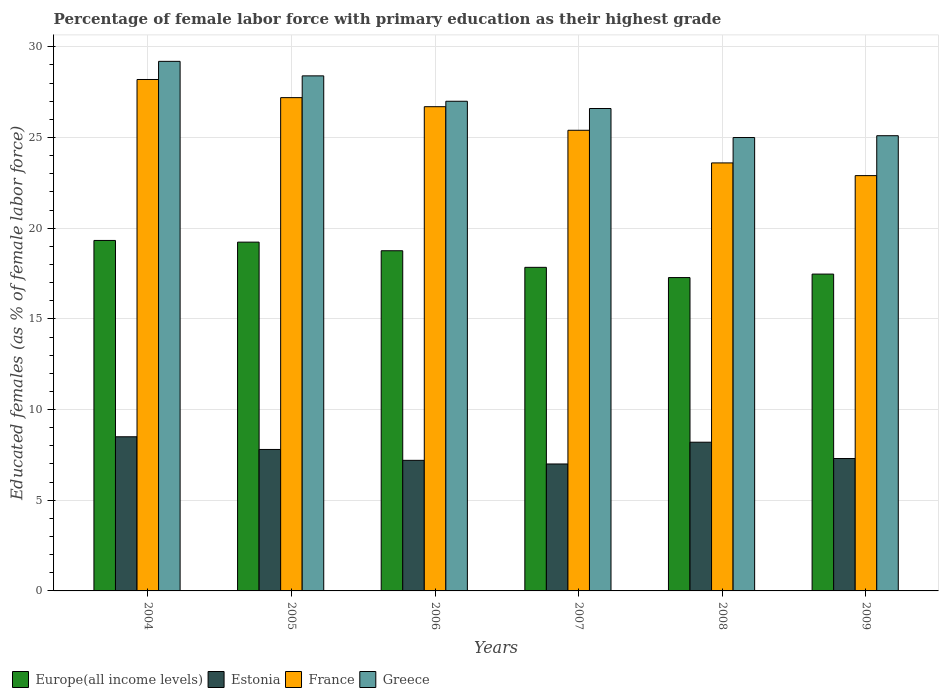How many different coloured bars are there?
Make the answer very short. 4. How many groups of bars are there?
Provide a succinct answer. 6. Are the number of bars per tick equal to the number of legend labels?
Ensure brevity in your answer.  Yes. Are the number of bars on each tick of the X-axis equal?
Your answer should be compact. Yes. What is the percentage of female labor force with primary education in Greece in 2009?
Make the answer very short. 25.1. Across all years, what is the maximum percentage of female labor force with primary education in Europe(all income levels)?
Provide a short and direct response. 19.32. Across all years, what is the minimum percentage of female labor force with primary education in France?
Keep it short and to the point. 22.9. In which year was the percentage of female labor force with primary education in Europe(all income levels) maximum?
Give a very brief answer. 2004. What is the total percentage of female labor force with primary education in Greece in the graph?
Provide a short and direct response. 161.3. What is the difference between the percentage of female labor force with primary education in Europe(all income levels) in 2004 and that in 2008?
Your answer should be compact. 2.05. What is the difference between the percentage of female labor force with primary education in Europe(all income levels) in 2007 and the percentage of female labor force with primary education in Estonia in 2004?
Offer a terse response. 9.34. What is the average percentage of female labor force with primary education in Estonia per year?
Provide a short and direct response. 7.67. In the year 2006, what is the difference between the percentage of female labor force with primary education in France and percentage of female labor force with primary education in Greece?
Your response must be concise. -0.3. In how many years, is the percentage of female labor force with primary education in Greece greater than 10 %?
Your answer should be compact. 6. What is the ratio of the percentage of female labor force with primary education in Europe(all income levels) in 2004 to that in 2006?
Your answer should be very brief. 1.03. Is the percentage of female labor force with primary education in Greece in 2005 less than that in 2009?
Provide a short and direct response. No. Is the difference between the percentage of female labor force with primary education in France in 2007 and 2009 greater than the difference between the percentage of female labor force with primary education in Greece in 2007 and 2009?
Give a very brief answer. Yes. What is the difference between the highest and the second highest percentage of female labor force with primary education in Europe(all income levels)?
Ensure brevity in your answer.  0.09. What is the difference between the highest and the lowest percentage of female labor force with primary education in Europe(all income levels)?
Your answer should be very brief. 2.05. In how many years, is the percentage of female labor force with primary education in Europe(all income levels) greater than the average percentage of female labor force with primary education in Europe(all income levels) taken over all years?
Provide a short and direct response. 3. Is the sum of the percentage of female labor force with primary education in France in 2005 and 2006 greater than the maximum percentage of female labor force with primary education in Europe(all income levels) across all years?
Make the answer very short. Yes. Is it the case that in every year, the sum of the percentage of female labor force with primary education in France and percentage of female labor force with primary education in Europe(all income levels) is greater than the sum of percentage of female labor force with primary education in Greece and percentage of female labor force with primary education in Estonia?
Your answer should be compact. No. What does the 1st bar from the left in 2007 represents?
Offer a very short reply. Europe(all income levels). What does the 4th bar from the right in 2007 represents?
Your response must be concise. Europe(all income levels). Is it the case that in every year, the sum of the percentage of female labor force with primary education in Greece and percentage of female labor force with primary education in Estonia is greater than the percentage of female labor force with primary education in Europe(all income levels)?
Your answer should be very brief. Yes. How many bars are there?
Provide a succinct answer. 24. Are all the bars in the graph horizontal?
Provide a succinct answer. No. What is the difference between two consecutive major ticks on the Y-axis?
Your answer should be very brief. 5. Are the values on the major ticks of Y-axis written in scientific E-notation?
Your answer should be very brief. No. Does the graph contain any zero values?
Keep it short and to the point. No. Where does the legend appear in the graph?
Make the answer very short. Bottom left. How many legend labels are there?
Provide a succinct answer. 4. How are the legend labels stacked?
Your answer should be compact. Horizontal. What is the title of the graph?
Your response must be concise. Percentage of female labor force with primary education as their highest grade. What is the label or title of the Y-axis?
Your response must be concise. Educated females (as % of female labor force). What is the Educated females (as % of female labor force) in Europe(all income levels) in 2004?
Keep it short and to the point. 19.32. What is the Educated females (as % of female labor force) of France in 2004?
Your response must be concise. 28.2. What is the Educated females (as % of female labor force) in Greece in 2004?
Your answer should be very brief. 29.2. What is the Educated females (as % of female labor force) of Europe(all income levels) in 2005?
Provide a succinct answer. 19.23. What is the Educated females (as % of female labor force) of Estonia in 2005?
Provide a short and direct response. 7.8. What is the Educated females (as % of female labor force) in France in 2005?
Offer a very short reply. 27.2. What is the Educated females (as % of female labor force) of Greece in 2005?
Make the answer very short. 28.4. What is the Educated females (as % of female labor force) in Europe(all income levels) in 2006?
Offer a terse response. 18.76. What is the Educated females (as % of female labor force) of Estonia in 2006?
Offer a terse response. 7.2. What is the Educated females (as % of female labor force) of France in 2006?
Offer a very short reply. 26.7. What is the Educated females (as % of female labor force) of Greece in 2006?
Ensure brevity in your answer.  27. What is the Educated females (as % of female labor force) of Europe(all income levels) in 2007?
Make the answer very short. 17.84. What is the Educated females (as % of female labor force) of France in 2007?
Offer a very short reply. 25.4. What is the Educated females (as % of female labor force) of Greece in 2007?
Ensure brevity in your answer.  26.6. What is the Educated females (as % of female labor force) in Europe(all income levels) in 2008?
Your response must be concise. 17.28. What is the Educated females (as % of female labor force) of Estonia in 2008?
Make the answer very short. 8.2. What is the Educated females (as % of female labor force) of France in 2008?
Give a very brief answer. 23.6. What is the Educated females (as % of female labor force) in Greece in 2008?
Ensure brevity in your answer.  25. What is the Educated females (as % of female labor force) in Europe(all income levels) in 2009?
Your answer should be very brief. 17.47. What is the Educated females (as % of female labor force) in Estonia in 2009?
Provide a succinct answer. 7.3. What is the Educated females (as % of female labor force) in France in 2009?
Give a very brief answer. 22.9. What is the Educated females (as % of female labor force) of Greece in 2009?
Your response must be concise. 25.1. Across all years, what is the maximum Educated females (as % of female labor force) in Europe(all income levels)?
Your answer should be compact. 19.32. Across all years, what is the maximum Educated females (as % of female labor force) in France?
Your answer should be compact. 28.2. Across all years, what is the maximum Educated females (as % of female labor force) in Greece?
Ensure brevity in your answer.  29.2. Across all years, what is the minimum Educated females (as % of female labor force) of Europe(all income levels)?
Make the answer very short. 17.28. Across all years, what is the minimum Educated females (as % of female labor force) in France?
Your response must be concise. 22.9. Across all years, what is the minimum Educated females (as % of female labor force) in Greece?
Keep it short and to the point. 25. What is the total Educated females (as % of female labor force) in Europe(all income levels) in the graph?
Offer a very short reply. 109.9. What is the total Educated females (as % of female labor force) in France in the graph?
Give a very brief answer. 154. What is the total Educated females (as % of female labor force) in Greece in the graph?
Make the answer very short. 161.3. What is the difference between the Educated females (as % of female labor force) of Europe(all income levels) in 2004 and that in 2005?
Ensure brevity in your answer.  0.09. What is the difference between the Educated females (as % of female labor force) of Europe(all income levels) in 2004 and that in 2006?
Offer a very short reply. 0.57. What is the difference between the Educated females (as % of female labor force) of France in 2004 and that in 2006?
Your answer should be very brief. 1.5. What is the difference between the Educated females (as % of female labor force) of Greece in 2004 and that in 2006?
Keep it short and to the point. 2.2. What is the difference between the Educated females (as % of female labor force) of Europe(all income levels) in 2004 and that in 2007?
Make the answer very short. 1.48. What is the difference between the Educated females (as % of female labor force) of Estonia in 2004 and that in 2007?
Your answer should be compact. 1.5. What is the difference between the Educated females (as % of female labor force) in France in 2004 and that in 2007?
Keep it short and to the point. 2.8. What is the difference between the Educated females (as % of female labor force) in Greece in 2004 and that in 2007?
Offer a terse response. 2.6. What is the difference between the Educated females (as % of female labor force) in Europe(all income levels) in 2004 and that in 2008?
Offer a very short reply. 2.05. What is the difference between the Educated females (as % of female labor force) of Estonia in 2004 and that in 2008?
Provide a succinct answer. 0.3. What is the difference between the Educated females (as % of female labor force) of France in 2004 and that in 2008?
Provide a succinct answer. 4.6. What is the difference between the Educated females (as % of female labor force) of Greece in 2004 and that in 2008?
Offer a very short reply. 4.2. What is the difference between the Educated females (as % of female labor force) in Europe(all income levels) in 2004 and that in 2009?
Your answer should be compact. 1.85. What is the difference between the Educated females (as % of female labor force) in Estonia in 2004 and that in 2009?
Keep it short and to the point. 1.2. What is the difference between the Educated females (as % of female labor force) in France in 2004 and that in 2009?
Your answer should be compact. 5.3. What is the difference between the Educated females (as % of female labor force) in Greece in 2004 and that in 2009?
Provide a succinct answer. 4.1. What is the difference between the Educated females (as % of female labor force) in Europe(all income levels) in 2005 and that in 2006?
Provide a succinct answer. 0.47. What is the difference between the Educated females (as % of female labor force) in Estonia in 2005 and that in 2006?
Ensure brevity in your answer.  0.6. What is the difference between the Educated females (as % of female labor force) in France in 2005 and that in 2006?
Give a very brief answer. 0.5. What is the difference between the Educated females (as % of female labor force) of Europe(all income levels) in 2005 and that in 2007?
Keep it short and to the point. 1.39. What is the difference between the Educated females (as % of female labor force) of Estonia in 2005 and that in 2007?
Provide a succinct answer. 0.8. What is the difference between the Educated females (as % of female labor force) of Europe(all income levels) in 2005 and that in 2008?
Your answer should be compact. 1.95. What is the difference between the Educated females (as % of female labor force) of Estonia in 2005 and that in 2008?
Provide a short and direct response. -0.4. What is the difference between the Educated females (as % of female labor force) of Greece in 2005 and that in 2008?
Your answer should be compact. 3.4. What is the difference between the Educated females (as % of female labor force) in Europe(all income levels) in 2005 and that in 2009?
Give a very brief answer. 1.76. What is the difference between the Educated females (as % of female labor force) of Europe(all income levels) in 2006 and that in 2007?
Provide a succinct answer. 0.92. What is the difference between the Educated females (as % of female labor force) of Estonia in 2006 and that in 2007?
Offer a terse response. 0.2. What is the difference between the Educated females (as % of female labor force) in Greece in 2006 and that in 2007?
Keep it short and to the point. 0.4. What is the difference between the Educated females (as % of female labor force) of Europe(all income levels) in 2006 and that in 2008?
Provide a succinct answer. 1.48. What is the difference between the Educated females (as % of female labor force) of Greece in 2006 and that in 2008?
Give a very brief answer. 2. What is the difference between the Educated females (as % of female labor force) in Europe(all income levels) in 2006 and that in 2009?
Make the answer very short. 1.29. What is the difference between the Educated females (as % of female labor force) in Estonia in 2006 and that in 2009?
Offer a very short reply. -0.1. What is the difference between the Educated females (as % of female labor force) of Europe(all income levels) in 2007 and that in 2008?
Keep it short and to the point. 0.56. What is the difference between the Educated females (as % of female labor force) of France in 2007 and that in 2008?
Make the answer very short. 1.8. What is the difference between the Educated females (as % of female labor force) of Greece in 2007 and that in 2008?
Your answer should be compact. 1.6. What is the difference between the Educated females (as % of female labor force) of Europe(all income levels) in 2007 and that in 2009?
Provide a short and direct response. 0.37. What is the difference between the Educated females (as % of female labor force) in Estonia in 2007 and that in 2009?
Your response must be concise. -0.3. What is the difference between the Educated females (as % of female labor force) of France in 2007 and that in 2009?
Ensure brevity in your answer.  2.5. What is the difference between the Educated females (as % of female labor force) in Greece in 2007 and that in 2009?
Make the answer very short. 1.5. What is the difference between the Educated females (as % of female labor force) of Europe(all income levels) in 2008 and that in 2009?
Give a very brief answer. -0.19. What is the difference between the Educated females (as % of female labor force) of Estonia in 2008 and that in 2009?
Your response must be concise. 0.9. What is the difference between the Educated females (as % of female labor force) of Europe(all income levels) in 2004 and the Educated females (as % of female labor force) of Estonia in 2005?
Offer a terse response. 11.52. What is the difference between the Educated females (as % of female labor force) of Europe(all income levels) in 2004 and the Educated females (as % of female labor force) of France in 2005?
Your answer should be compact. -7.88. What is the difference between the Educated females (as % of female labor force) of Europe(all income levels) in 2004 and the Educated females (as % of female labor force) of Greece in 2005?
Provide a succinct answer. -9.08. What is the difference between the Educated females (as % of female labor force) in Estonia in 2004 and the Educated females (as % of female labor force) in France in 2005?
Your response must be concise. -18.7. What is the difference between the Educated females (as % of female labor force) in Estonia in 2004 and the Educated females (as % of female labor force) in Greece in 2005?
Offer a terse response. -19.9. What is the difference between the Educated females (as % of female labor force) in France in 2004 and the Educated females (as % of female labor force) in Greece in 2005?
Your response must be concise. -0.2. What is the difference between the Educated females (as % of female labor force) in Europe(all income levels) in 2004 and the Educated females (as % of female labor force) in Estonia in 2006?
Your response must be concise. 12.12. What is the difference between the Educated females (as % of female labor force) of Europe(all income levels) in 2004 and the Educated females (as % of female labor force) of France in 2006?
Your response must be concise. -7.38. What is the difference between the Educated females (as % of female labor force) of Europe(all income levels) in 2004 and the Educated females (as % of female labor force) of Greece in 2006?
Ensure brevity in your answer.  -7.68. What is the difference between the Educated females (as % of female labor force) in Estonia in 2004 and the Educated females (as % of female labor force) in France in 2006?
Offer a very short reply. -18.2. What is the difference between the Educated females (as % of female labor force) of Estonia in 2004 and the Educated females (as % of female labor force) of Greece in 2006?
Your answer should be compact. -18.5. What is the difference between the Educated females (as % of female labor force) of Europe(all income levels) in 2004 and the Educated females (as % of female labor force) of Estonia in 2007?
Your answer should be compact. 12.32. What is the difference between the Educated females (as % of female labor force) in Europe(all income levels) in 2004 and the Educated females (as % of female labor force) in France in 2007?
Provide a short and direct response. -6.08. What is the difference between the Educated females (as % of female labor force) of Europe(all income levels) in 2004 and the Educated females (as % of female labor force) of Greece in 2007?
Ensure brevity in your answer.  -7.28. What is the difference between the Educated females (as % of female labor force) of Estonia in 2004 and the Educated females (as % of female labor force) of France in 2007?
Your answer should be compact. -16.9. What is the difference between the Educated females (as % of female labor force) in Estonia in 2004 and the Educated females (as % of female labor force) in Greece in 2007?
Your response must be concise. -18.1. What is the difference between the Educated females (as % of female labor force) of Europe(all income levels) in 2004 and the Educated females (as % of female labor force) of Estonia in 2008?
Give a very brief answer. 11.12. What is the difference between the Educated females (as % of female labor force) in Europe(all income levels) in 2004 and the Educated females (as % of female labor force) in France in 2008?
Your answer should be compact. -4.28. What is the difference between the Educated females (as % of female labor force) in Europe(all income levels) in 2004 and the Educated females (as % of female labor force) in Greece in 2008?
Offer a terse response. -5.68. What is the difference between the Educated females (as % of female labor force) of Estonia in 2004 and the Educated females (as % of female labor force) of France in 2008?
Keep it short and to the point. -15.1. What is the difference between the Educated females (as % of female labor force) of Estonia in 2004 and the Educated females (as % of female labor force) of Greece in 2008?
Make the answer very short. -16.5. What is the difference between the Educated females (as % of female labor force) in France in 2004 and the Educated females (as % of female labor force) in Greece in 2008?
Provide a succinct answer. 3.2. What is the difference between the Educated females (as % of female labor force) in Europe(all income levels) in 2004 and the Educated females (as % of female labor force) in Estonia in 2009?
Provide a succinct answer. 12.02. What is the difference between the Educated females (as % of female labor force) in Europe(all income levels) in 2004 and the Educated females (as % of female labor force) in France in 2009?
Offer a terse response. -3.58. What is the difference between the Educated females (as % of female labor force) of Europe(all income levels) in 2004 and the Educated females (as % of female labor force) of Greece in 2009?
Keep it short and to the point. -5.78. What is the difference between the Educated females (as % of female labor force) in Estonia in 2004 and the Educated females (as % of female labor force) in France in 2009?
Make the answer very short. -14.4. What is the difference between the Educated females (as % of female labor force) in Estonia in 2004 and the Educated females (as % of female labor force) in Greece in 2009?
Ensure brevity in your answer.  -16.6. What is the difference between the Educated females (as % of female labor force) of France in 2004 and the Educated females (as % of female labor force) of Greece in 2009?
Your answer should be very brief. 3.1. What is the difference between the Educated females (as % of female labor force) of Europe(all income levels) in 2005 and the Educated females (as % of female labor force) of Estonia in 2006?
Your answer should be compact. 12.03. What is the difference between the Educated females (as % of female labor force) of Europe(all income levels) in 2005 and the Educated females (as % of female labor force) of France in 2006?
Your answer should be very brief. -7.47. What is the difference between the Educated females (as % of female labor force) in Europe(all income levels) in 2005 and the Educated females (as % of female labor force) in Greece in 2006?
Offer a terse response. -7.77. What is the difference between the Educated females (as % of female labor force) in Estonia in 2005 and the Educated females (as % of female labor force) in France in 2006?
Keep it short and to the point. -18.9. What is the difference between the Educated females (as % of female labor force) of Estonia in 2005 and the Educated females (as % of female labor force) of Greece in 2006?
Provide a succinct answer. -19.2. What is the difference between the Educated females (as % of female labor force) in France in 2005 and the Educated females (as % of female labor force) in Greece in 2006?
Your answer should be very brief. 0.2. What is the difference between the Educated females (as % of female labor force) in Europe(all income levels) in 2005 and the Educated females (as % of female labor force) in Estonia in 2007?
Your answer should be very brief. 12.23. What is the difference between the Educated females (as % of female labor force) in Europe(all income levels) in 2005 and the Educated females (as % of female labor force) in France in 2007?
Your answer should be compact. -6.17. What is the difference between the Educated females (as % of female labor force) in Europe(all income levels) in 2005 and the Educated females (as % of female labor force) in Greece in 2007?
Provide a short and direct response. -7.37. What is the difference between the Educated females (as % of female labor force) in Estonia in 2005 and the Educated females (as % of female labor force) in France in 2007?
Offer a terse response. -17.6. What is the difference between the Educated females (as % of female labor force) of Estonia in 2005 and the Educated females (as % of female labor force) of Greece in 2007?
Your answer should be compact. -18.8. What is the difference between the Educated females (as % of female labor force) of France in 2005 and the Educated females (as % of female labor force) of Greece in 2007?
Provide a succinct answer. 0.6. What is the difference between the Educated females (as % of female labor force) in Europe(all income levels) in 2005 and the Educated females (as % of female labor force) in Estonia in 2008?
Provide a short and direct response. 11.03. What is the difference between the Educated females (as % of female labor force) of Europe(all income levels) in 2005 and the Educated females (as % of female labor force) of France in 2008?
Offer a terse response. -4.37. What is the difference between the Educated females (as % of female labor force) of Europe(all income levels) in 2005 and the Educated females (as % of female labor force) of Greece in 2008?
Offer a terse response. -5.77. What is the difference between the Educated females (as % of female labor force) in Estonia in 2005 and the Educated females (as % of female labor force) in France in 2008?
Offer a very short reply. -15.8. What is the difference between the Educated females (as % of female labor force) of Estonia in 2005 and the Educated females (as % of female labor force) of Greece in 2008?
Your response must be concise. -17.2. What is the difference between the Educated females (as % of female labor force) in France in 2005 and the Educated females (as % of female labor force) in Greece in 2008?
Your answer should be very brief. 2.2. What is the difference between the Educated females (as % of female labor force) of Europe(all income levels) in 2005 and the Educated females (as % of female labor force) of Estonia in 2009?
Provide a succinct answer. 11.93. What is the difference between the Educated females (as % of female labor force) in Europe(all income levels) in 2005 and the Educated females (as % of female labor force) in France in 2009?
Your answer should be compact. -3.67. What is the difference between the Educated females (as % of female labor force) in Europe(all income levels) in 2005 and the Educated females (as % of female labor force) in Greece in 2009?
Your answer should be very brief. -5.87. What is the difference between the Educated females (as % of female labor force) in Estonia in 2005 and the Educated females (as % of female labor force) in France in 2009?
Ensure brevity in your answer.  -15.1. What is the difference between the Educated females (as % of female labor force) of Estonia in 2005 and the Educated females (as % of female labor force) of Greece in 2009?
Provide a short and direct response. -17.3. What is the difference between the Educated females (as % of female labor force) in France in 2005 and the Educated females (as % of female labor force) in Greece in 2009?
Keep it short and to the point. 2.1. What is the difference between the Educated females (as % of female labor force) in Europe(all income levels) in 2006 and the Educated females (as % of female labor force) in Estonia in 2007?
Keep it short and to the point. 11.76. What is the difference between the Educated females (as % of female labor force) in Europe(all income levels) in 2006 and the Educated females (as % of female labor force) in France in 2007?
Give a very brief answer. -6.64. What is the difference between the Educated females (as % of female labor force) of Europe(all income levels) in 2006 and the Educated females (as % of female labor force) of Greece in 2007?
Your answer should be compact. -7.84. What is the difference between the Educated females (as % of female labor force) in Estonia in 2006 and the Educated females (as % of female labor force) in France in 2007?
Your response must be concise. -18.2. What is the difference between the Educated females (as % of female labor force) of Estonia in 2006 and the Educated females (as % of female labor force) of Greece in 2007?
Give a very brief answer. -19.4. What is the difference between the Educated females (as % of female labor force) of Europe(all income levels) in 2006 and the Educated females (as % of female labor force) of Estonia in 2008?
Provide a short and direct response. 10.56. What is the difference between the Educated females (as % of female labor force) in Europe(all income levels) in 2006 and the Educated females (as % of female labor force) in France in 2008?
Your answer should be very brief. -4.84. What is the difference between the Educated females (as % of female labor force) of Europe(all income levels) in 2006 and the Educated females (as % of female labor force) of Greece in 2008?
Provide a succinct answer. -6.24. What is the difference between the Educated females (as % of female labor force) in Estonia in 2006 and the Educated females (as % of female labor force) in France in 2008?
Your answer should be compact. -16.4. What is the difference between the Educated females (as % of female labor force) of Estonia in 2006 and the Educated females (as % of female labor force) of Greece in 2008?
Offer a very short reply. -17.8. What is the difference between the Educated females (as % of female labor force) of Europe(all income levels) in 2006 and the Educated females (as % of female labor force) of Estonia in 2009?
Provide a short and direct response. 11.46. What is the difference between the Educated females (as % of female labor force) of Europe(all income levels) in 2006 and the Educated females (as % of female labor force) of France in 2009?
Offer a terse response. -4.14. What is the difference between the Educated females (as % of female labor force) in Europe(all income levels) in 2006 and the Educated females (as % of female labor force) in Greece in 2009?
Provide a succinct answer. -6.34. What is the difference between the Educated females (as % of female labor force) in Estonia in 2006 and the Educated females (as % of female labor force) in France in 2009?
Keep it short and to the point. -15.7. What is the difference between the Educated females (as % of female labor force) of Estonia in 2006 and the Educated females (as % of female labor force) of Greece in 2009?
Provide a succinct answer. -17.9. What is the difference between the Educated females (as % of female labor force) in France in 2006 and the Educated females (as % of female labor force) in Greece in 2009?
Offer a very short reply. 1.6. What is the difference between the Educated females (as % of female labor force) in Europe(all income levels) in 2007 and the Educated females (as % of female labor force) in Estonia in 2008?
Offer a very short reply. 9.64. What is the difference between the Educated females (as % of female labor force) of Europe(all income levels) in 2007 and the Educated females (as % of female labor force) of France in 2008?
Give a very brief answer. -5.76. What is the difference between the Educated females (as % of female labor force) in Europe(all income levels) in 2007 and the Educated females (as % of female labor force) in Greece in 2008?
Give a very brief answer. -7.16. What is the difference between the Educated females (as % of female labor force) of Estonia in 2007 and the Educated females (as % of female labor force) of France in 2008?
Your answer should be compact. -16.6. What is the difference between the Educated females (as % of female labor force) of Estonia in 2007 and the Educated females (as % of female labor force) of Greece in 2008?
Give a very brief answer. -18. What is the difference between the Educated females (as % of female labor force) of France in 2007 and the Educated females (as % of female labor force) of Greece in 2008?
Provide a succinct answer. 0.4. What is the difference between the Educated females (as % of female labor force) of Europe(all income levels) in 2007 and the Educated females (as % of female labor force) of Estonia in 2009?
Offer a terse response. 10.54. What is the difference between the Educated females (as % of female labor force) of Europe(all income levels) in 2007 and the Educated females (as % of female labor force) of France in 2009?
Make the answer very short. -5.06. What is the difference between the Educated females (as % of female labor force) of Europe(all income levels) in 2007 and the Educated females (as % of female labor force) of Greece in 2009?
Offer a terse response. -7.26. What is the difference between the Educated females (as % of female labor force) of Estonia in 2007 and the Educated females (as % of female labor force) of France in 2009?
Make the answer very short. -15.9. What is the difference between the Educated females (as % of female labor force) of Estonia in 2007 and the Educated females (as % of female labor force) of Greece in 2009?
Offer a very short reply. -18.1. What is the difference between the Educated females (as % of female labor force) of Europe(all income levels) in 2008 and the Educated females (as % of female labor force) of Estonia in 2009?
Your response must be concise. 9.98. What is the difference between the Educated females (as % of female labor force) in Europe(all income levels) in 2008 and the Educated females (as % of female labor force) in France in 2009?
Make the answer very short. -5.62. What is the difference between the Educated females (as % of female labor force) of Europe(all income levels) in 2008 and the Educated females (as % of female labor force) of Greece in 2009?
Offer a very short reply. -7.82. What is the difference between the Educated females (as % of female labor force) in Estonia in 2008 and the Educated females (as % of female labor force) in France in 2009?
Offer a very short reply. -14.7. What is the difference between the Educated females (as % of female labor force) in Estonia in 2008 and the Educated females (as % of female labor force) in Greece in 2009?
Offer a very short reply. -16.9. What is the average Educated females (as % of female labor force) of Europe(all income levels) per year?
Your response must be concise. 18.32. What is the average Educated females (as % of female labor force) in Estonia per year?
Ensure brevity in your answer.  7.67. What is the average Educated females (as % of female labor force) in France per year?
Ensure brevity in your answer.  25.67. What is the average Educated females (as % of female labor force) of Greece per year?
Offer a very short reply. 26.88. In the year 2004, what is the difference between the Educated females (as % of female labor force) of Europe(all income levels) and Educated females (as % of female labor force) of Estonia?
Ensure brevity in your answer.  10.82. In the year 2004, what is the difference between the Educated females (as % of female labor force) in Europe(all income levels) and Educated females (as % of female labor force) in France?
Your answer should be compact. -8.88. In the year 2004, what is the difference between the Educated females (as % of female labor force) in Europe(all income levels) and Educated females (as % of female labor force) in Greece?
Your answer should be compact. -9.88. In the year 2004, what is the difference between the Educated females (as % of female labor force) of Estonia and Educated females (as % of female labor force) of France?
Offer a terse response. -19.7. In the year 2004, what is the difference between the Educated females (as % of female labor force) in Estonia and Educated females (as % of female labor force) in Greece?
Offer a terse response. -20.7. In the year 2005, what is the difference between the Educated females (as % of female labor force) of Europe(all income levels) and Educated females (as % of female labor force) of Estonia?
Your response must be concise. 11.43. In the year 2005, what is the difference between the Educated females (as % of female labor force) of Europe(all income levels) and Educated females (as % of female labor force) of France?
Provide a succinct answer. -7.97. In the year 2005, what is the difference between the Educated females (as % of female labor force) of Europe(all income levels) and Educated females (as % of female labor force) of Greece?
Provide a short and direct response. -9.17. In the year 2005, what is the difference between the Educated females (as % of female labor force) in Estonia and Educated females (as % of female labor force) in France?
Your answer should be compact. -19.4. In the year 2005, what is the difference between the Educated females (as % of female labor force) of Estonia and Educated females (as % of female labor force) of Greece?
Ensure brevity in your answer.  -20.6. In the year 2005, what is the difference between the Educated females (as % of female labor force) in France and Educated females (as % of female labor force) in Greece?
Your response must be concise. -1.2. In the year 2006, what is the difference between the Educated females (as % of female labor force) of Europe(all income levels) and Educated females (as % of female labor force) of Estonia?
Offer a very short reply. 11.56. In the year 2006, what is the difference between the Educated females (as % of female labor force) of Europe(all income levels) and Educated females (as % of female labor force) of France?
Give a very brief answer. -7.94. In the year 2006, what is the difference between the Educated females (as % of female labor force) in Europe(all income levels) and Educated females (as % of female labor force) in Greece?
Your answer should be very brief. -8.24. In the year 2006, what is the difference between the Educated females (as % of female labor force) of Estonia and Educated females (as % of female labor force) of France?
Keep it short and to the point. -19.5. In the year 2006, what is the difference between the Educated females (as % of female labor force) of Estonia and Educated females (as % of female labor force) of Greece?
Your answer should be compact. -19.8. In the year 2006, what is the difference between the Educated females (as % of female labor force) of France and Educated females (as % of female labor force) of Greece?
Give a very brief answer. -0.3. In the year 2007, what is the difference between the Educated females (as % of female labor force) of Europe(all income levels) and Educated females (as % of female labor force) of Estonia?
Your response must be concise. 10.84. In the year 2007, what is the difference between the Educated females (as % of female labor force) in Europe(all income levels) and Educated females (as % of female labor force) in France?
Your response must be concise. -7.56. In the year 2007, what is the difference between the Educated females (as % of female labor force) of Europe(all income levels) and Educated females (as % of female labor force) of Greece?
Offer a terse response. -8.76. In the year 2007, what is the difference between the Educated females (as % of female labor force) in Estonia and Educated females (as % of female labor force) in France?
Provide a short and direct response. -18.4. In the year 2007, what is the difference between the Educated females (as % of female labor force) of Estonia and Educated females (as % of female labor force) of Greece?
Your answer should be very brief. -19.6. In the year 2008, what is the difference between the Educated females (as % of female labor force) in Europe(all income levels) and Educated females (as % of female labor force) in Estonia?
Ensure brevity in your answer.  9.08. In the year 2008, what is the difference between the Educated females (as % of female labor force) in Europe(all income levels) and Educated females (as % of female labor force) in France?
Your answer should be compact. -6.32. In the year 2008, what is the difference between the Educated females (as % of female labor force) of Europe(all income levels) and Educated females (as % of female labor force) of Greece?
Ensure brevity in your answer.  -7.72. In the year 2008, what is the difference between the Educated females (as % of female labor force) of Estonia and Educated females (as % of female labor force) of France?
Offer a terse response. -15.4. In the year 2008, what is the difference between the Educated females (as % of female labor force) in Estonia and Educated females (as % of female labor force) in Greece?
Provide a succinct answer. -16.8. In the year 2008, what is the difference between the Educated females (as % of female labor force) in France and Educated females (as % of female labor force) in Greece?
Make the answer very short. -1.4. In the year 2009, what is the difference between the Educated females (as % of female labor force) of Europe(all income levels) and Educated females (as % of female labor force) of Estonia?
Provide a succinct answer. 10.17. In the year 2009, what is the difference between the Educated females (as % of female labor force) of Europe(all income levels) and Educated females (as % of female labor force) of France?
Your answer should be compact. -5.43. In the year 2009, what is the difference between the Educated females (as % of female labor force) in Europe(all income levels) and Educated females (as % of female labor force) in Greece?
Your answer should be very brief. -7.63. In the year 2009, what is the difference between the Educated females (as % of female labor force) of Estonia and Educated females (as % of female labor force) of France?
Ensure brevity in your answer.  -15.6. In the year 2009, what is the difference between the Educated females (as % of female labor force) in Estonia and Educated females (as % of female labor force) in Greece?
Offer a terse response. -17.8. What is the ratio of the Educated females (as % of female labor force) in Europe(all income levels) in 2004 to that in 2005?
Keep it short and to the point. 1. What is the ratio of the Educated females (as % of female labor force) of Estonia in 2004 to that in 2005?
Your response must be concise. 1.09. What is the ratio of the Educated females (as % of female labor force) of France in 2004 to that in 2005?
Provide a short and direct response. 1.04. What is the ratio of the Educated females (as % of female labor force) of Greece in 2004 to that in 2005?
Offer a terse response. 1.03. What is the ratio of the Educated females (as % of female labor force) in Europe(all income levels) in 2004 to that in 2006?
Provide a short and direct response. 1.03. What is the ratio of the Educated females (as % of female labor force) in Estonia in 2004 to that in 2006?
Ensure brevity in your answer.  1.18. What is the ratio of the Educated females (as % of female labor force) of France in 2004 to that in 2006?
Offer a very short reply. 1.06. What is the ratio of the Educated females (as % of female labor force) in Greece in 2004 to that in 2006?
Your answer should be compact. 1.08. What is the ratio of the Educated females (as % of female labor force) of Europe(all income levels) in 2004 to that in 2007?
Your answer should be compact. 1.08. What is the ratio of the Educated females (as % of female labor force) of Estonia in 2004 to that in 2007?
Ensure brevity in your answer.  1.21. What is the ratio of the Educated females (as % of female labor force) in France in 2004 to that in 2007?
Your answer should be compact. 1.11. What is the ratio of the Educated females (as % of female labor force) of Greece in 2004 to that in 2007?
Provide a short and direct response. 1.1. What is the ratio of the Educated females (as % of female labor force) in Europe(all income levels) in 2004 to that in 2008?
Provide a short and direct response. 1.12. What is the ratio of the Educated females (as % of female labor force) in Estonia in 2004 to that in 2008?
Provide a succinct answer. 1.04. What is the ratio of the Educated females (as % of female labor force) in France in 2004 to that in 2008?
Provide a succinct answer. 1.19. What is the ratio of the Educated females (as % of female labor force) of Greece in 2004 to that in 2008?
Your answer should be compact. 1.17. What is the ratio of the Educated females (as % of female labor force) of Europe(all income levels) in 2004 to that in 2009?
Your answer should be compact. 1.11. What is the ratio of the Educated females (as % of female labor force) in Estonia in 2004 to that in 2009?
Your response must be concise. 1.16. What is the ratio of the Educated females (as % of female labor force) of France in 2004 to that in 2009?
Your answer should be compact. 1.23. What is the ratio of the Educated females (as % of female labor force) in Greece in 2004 to that in 2009?
Keep it short and to the point. 1.16. What is the ratio of the Educated females (as % of female labor force) in Europe(all income levels) in 2005 to that in 2006?
Your response must be concise. 1.03. What is the ratio of the Educated females (as % of female labor force) in Estonia in 2005 to that in 2006?
Your answer should be compact. 1.08. What is the ratio of the Educated females (as % of female labor force) in France in 2005 to that in 2006?
Make the answer very short. 1.02. What is the ratio of the Educated females (as % of female labor force) in Greece in 2005 to that in 2006?
Make the answer very short. 1.05. What is the ratio of the Educated females (as % of female labor force) in Europe(all income levels) in 2005 to that in 2007?
Your response must be concise. 1.08. What is the ratio of the Educated females (as % of female labor force) in Estonia in 2005 to that in 2007?
Give a very brief answer. 1.11. What is the ratio of the Educated females (as % of female labor force) of France in 2005 to that in 2007?
Your answer should be compact. 1.07. What is the ratio of the Educated females (as % of female labor force) of Greece in 2005 to that in 2007?
Keep it short and to the point. 1.07. What is the ratio of the Educated females (as % of female labor force) in Europe(all income levels) in 2005 to that in 2008?
Provide a short and direct response. 1.11. What is the ratio of the Educated females (as % of female labor force) of Estonia in 2005 to that in 2008?
Your response must be concise. 0.95. What is the ratio of the Educated females (as % of female labor force) in France in 2005 to that in 2008?
Your answer should be very brief. 1.15. What is the ratio of the Educated females (as % of female labor force) of Greece in 2005 to that in 2008?
Provide a short and direct response. 1.14. What is the ratio of the Educated females (as % of female labor force) of Europe(all income levels) in 2005 to that in 2009?
Keep it short and to the point. 1.1. What is the ratio of the Educated females (as % of female labor force) in Estonia in 2005 to that in 2009?
Keep it short and to the point. 1.07. What is the ratio of the Educated females (as % of female labor force) of France in 2005 to that in 2009?
Keep it short and to the point. 1.19. What is the ratio of the Educated females (as % of female labor force) of Greece in 2005 to that in 2009?
Your answer should be compact. 1.13. What is the ratio of the Educated females (as % of female labor force) of Europe(all income levels) in 2006 to that in 2007?
Offer a very short reply. 1.05. What is the ratio of the Educated females (as % of female labor force) of Estonia in 2006 to that in 2007?
Your response must be concise. 1.03. What is the ratio of the Educated females (as % of female labor force) in France in 2006 to that in 2007?
Offer a very short reply. 1.05. What is the ratio of the Educated females (as % of female labor force) in Europe(all income levels) in 2006 to that in 2008?
Ensure brevity in your answer.  1.09. What is the ratio of the Educated females (as % of female labor force) of Estonia in 2006 to that in 2008?
Provide a succinct answer. 0.88. What is the ratio of the Educated females (as % of female labor force) in France in 2006 to that in 2008?
Keep it short and to the point. 1.13. What is the ratio of the Educated females (as % of female labor force) of Greece in 2006 to that in 2008?
Your answer should be very brief. 1.08. What is the ratio of the Educated females (as % of female labor force) in Europe(all income levels) in 2006 to that in 2009?
Your response must be concise. 1.07. What is the ratio of the Educated females (as % of female labor force) of Estonia in 2006 to that in 2009?
Your answer should be very brief. 0.99. What is the ratio of the Educated females (as % of female labor force) of France in 2006 to that in 2009?
Ensure brevity in your answer.  1.17. What is the ratio of the Educated females (as % of female labor force) in Greece in 2006 to that in 2009?
Provide a succinct answer. 1.08. What is the ratio of the Educated females (as % of female labor force) of Europe(all income levels) in 2007 to that in 2008?
Provide a short and direct response. 1.03. What is the ratio of the Educated females (as % of female labor force) of Estonia in 2007 to that in 2008?
Keep it short and to the point. 0.85. What is the ratio of the Educated females (as % of female labor force) of France in 2007 to that in 2008?
Give a very brief answer. 1.08. What is the ratio of the Educated females (as % of female labor force) in Greece in 2007 to that in 2008?
Your answer should be compact. 1.06. What is the ratio of the Educated females (as % of female labor force) of Europe(all income levels) in 2007 to that in 2009?
Offer a very short reply. 1.02. What is the ratio of the Educated females (as % of female labor force) in Estonia in 2007 to that in 2009?
Keep it short and to the point. 0.96. What is the ratio of the Educated females (as % of female labor force) of France in 2007 to that in 2009?
Your answer should be compact. 1.11. What is the ratio of the Educated females (as % of female labor force) in Greece in 2007 to that in 2009?
Ensure brevity in your answer.  1.06. What is the ratio of the Educated females (as % of female labor force) of Europe(all income levels) in 2008 to that in 2009?
Provide a short and direct response. 0.99. What is the ratio of the Educated females (as % of female labor force) in Estonia in 2008 to that in 2009?
Your answer should be compact. 1.12. What is the ratio of the Educated females (as % of female labor force) in France in 2008 to that in 2009?
Provide a short and direct response. 1.03. What is the difference between the highest and the second highest Educated females (as % of female labor force) of Europe(all income levels)?
Your response must be concise. 0.09. What is the difference between the highest and the second highest Educated females (as % of female labor force) in Estonia?
Your response must be concise. 0.3. What is the difference between the highest and the second highest Educated females (as % of female labor force) of France?
Make the answer very short. 1. What is the difference between the highest and the lowest Educated females (as % of female labor force) of Europe(all income levels)?
Give a very brief answer. 2.05. What is the difference between the highest and the lowest Educated females (as % of female labor force) of Greece?
Offer a very short reply. 4.2. 